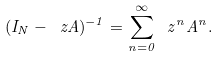Convert formula to latex. <formula><loc_0><loc_0><loc_500><loc_500>( I _ { N } - \ z A ) ^ { - 1 } = \sum _ { n = 0 } ^ { \infty } \ z ^ { n } A ^ { n } .</formula> 